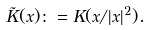<formula> <loc_0><loc_0><loc_500><loc_500>\tilde { K } ( x ) \colon = K ( x / | x | ^ { 2 } ) .</formula> 